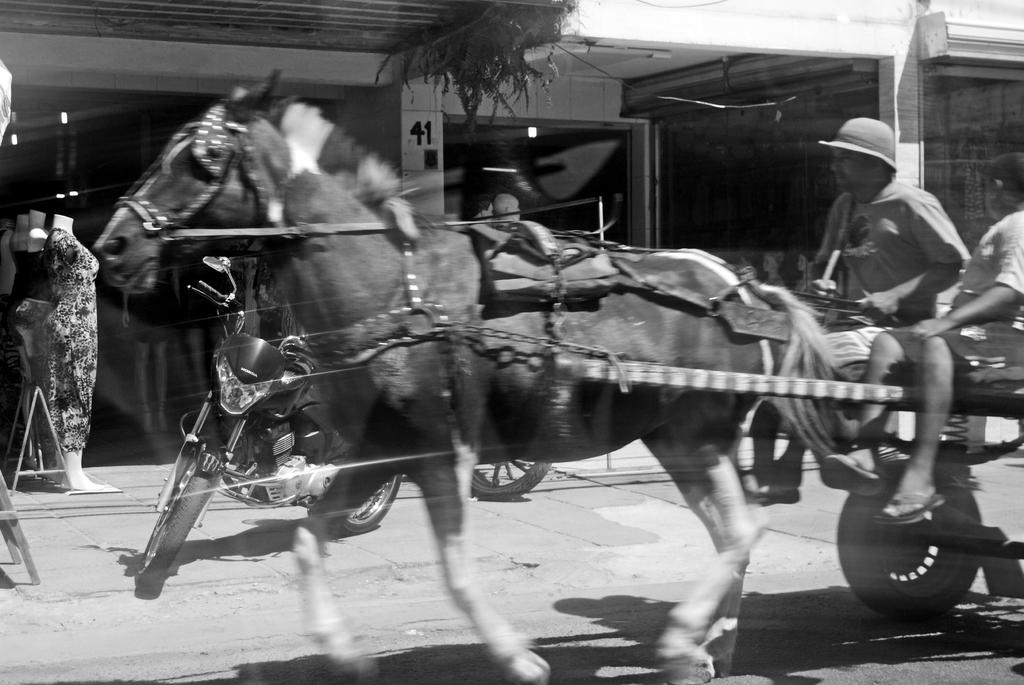What is the color scheme of the image? The image is black and white. What are the two people doing in the image? They are riding a horse cart. What type of vehicle can be seen in the image? There is a motor vehicle visible in the image. What type of natural elements are present in the image? Plants are present in the image. What type of inanimate objects are present in the image? There are mannequins in the image. What type of structure is visible in the image? There is a building in the image. What type of sink can be seen in the image? There is no sink present in the image. What type of class is being taught in the image? There is no class or teaching activity depicted in the image. 